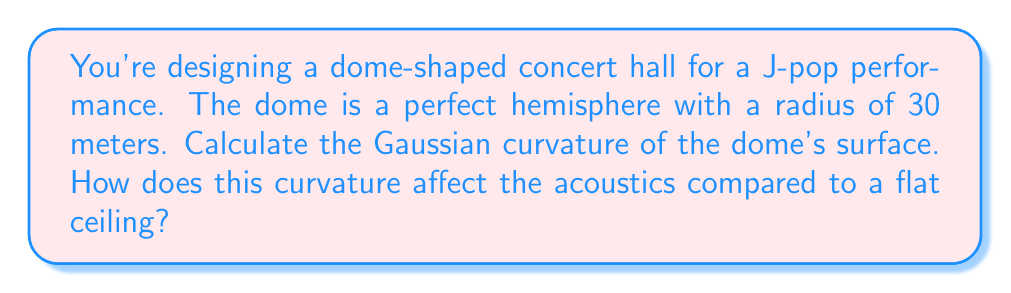Can you answer this question? Let's approach this step-by-step:

1) For a sphere, the Gaussian curvature (K) is constant at every point and is given by:

   $$K = \frac{1}{R^2}$$

   where R is the radius of the sphere.

2) We're given that the radius of the hemispherical dome is 30 meters. Let's substitute this into our equation:

   $$K = \frac{1}{(30\text{ m})^2} = \frac{1}{900\text{ m}^2} \approx 0.001111\text{ m}^{-2}$$

3) To understand how this affects acoustics, let's consider the following:

   a) A flat ceiling has a Gaussian curvature of 0.
   
   b) Positive curvature, as in our dome, causes sound waves to focus.
   
   c) The magnitude of curvature affects the degree of focusing.

4) In this case:
   
   - The positive curvature will cause sound to focus towards the center of the hall.
   - This can create "hot spots" where sound is intensified and "dead spots" where it's weaker.
   - The relatively low curvature (close to 0) means this effect will be present but not extreme.
   - This can enhance the immersive experience for a J-pop concert, creating a sense of sound "surrounding" the audience.

5) However, care must be taken in the acoustic design to prevent echoes or excessive focusing that could distort the sound.
Answer: $K \approx 0.001111\text{ m}^{-2}$; positive curvature focuses sound, creating an immersive experience but requiring careful acoustic design. 